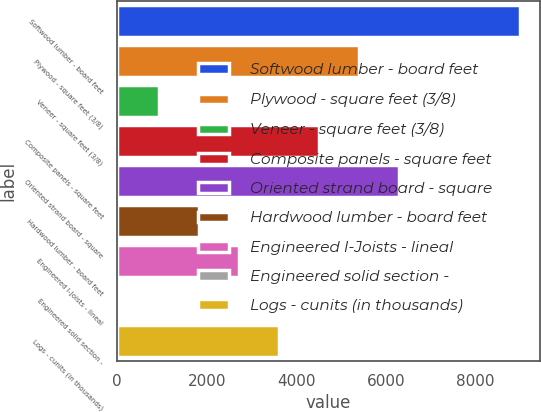Convert chart. <chart><loc_0><loc_0><loc_500><loc_500><bar_chart><fcel>Softwood lumber - board feet<fcel>Plywood - square feet (3/8)<fcel>Veneer - square feet (3/8)<fcel>Composite panels - square feet<fcel>Oriented strand board - square<fcel>Hardwood lumber - board feet<fcel>Engineered I-Joists - lineal<fcel>Engineered solid section -<fcel>Logs - cunits (in thousands)<nl><fcel>8981<fcel>5401.4<fcel>926.9<fcel>4506.5<fcel>6296.3<fcel>1821.8<fcel>2716.7<fcel>32<fcel>3611.6<nl></chart> 